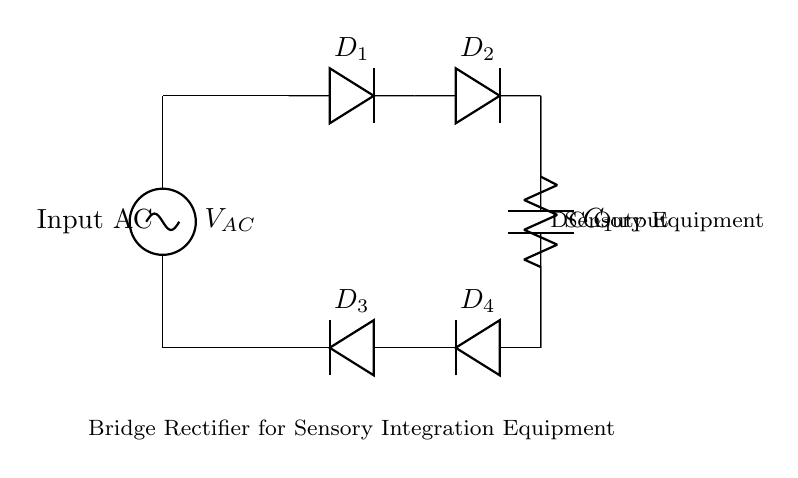What type of rectifier is presented in the circuit? The circuit employs a bridge rectifier, which is identified by the four diodes arranged in a bridge configuration. Each diode conducts during different halves of the AC input waveform to produce a unidirectional output.
Answer: bridge rectifier How many diodes are used in this circuit? There are four diodes in the bridge rectifier circuit. Each diode connects to the AC voltage source and the output capacitor to rectify the AC input into DC output.
Answer: four What is the purpose of the capacitor in this circuit? The capacitor serves to smooth the output voltage from the rectifier. After rectification, the DC voltage has a rippled waveform, and the capacitor charges and discharges to reduce this ripple, providing a more stable DC output for the load.
Answer: smooth output What type of load is connected at the output of the circuit? The load connected at the output is sensory equipment, which can vary in terms of power requirements but generally needs a stable DC voltage to function correctly.
Answer: sensory equipment How does the output voltage relate to the input AC voltage? The output DC voltage from the bridge rectifier circuit is typically less than the peak input AC voltage due to the voltage drop across the diodes. This drop can often be about 1.4 volts total for the two conducting diodes in the reverse direction for each half-cycle.
Answer: less than peak AC What are the two connections for the input AC in this circuit? The input AC connections are made at the top and bottom terminals where the AC source is connected, labeled in the circuit as the input terminals. One connection is at the positive half-cycle and the other at the negative half-cycle of the AC source.
Answer: top and bottom terminals 